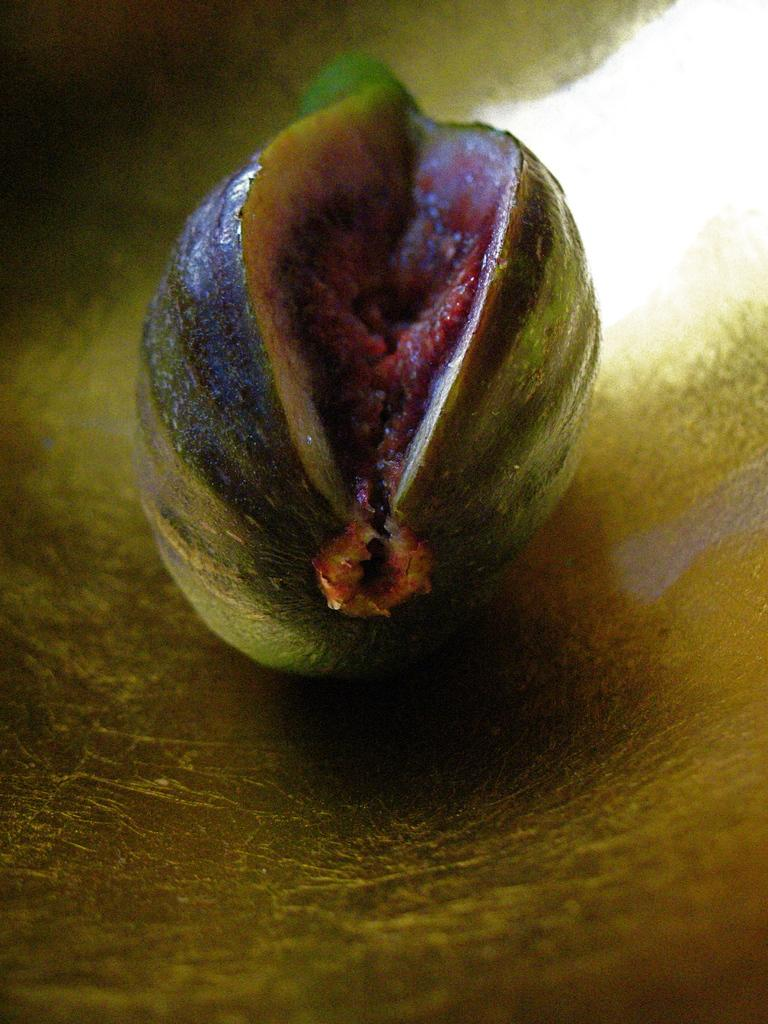What is the main subject of the image? The main subject of the image is a fruit. Can you describe the appearance of the fruit? The fruit is green and red in color. What type of thumb can be seen holding the fruit in the image? There is no thumb present in the image; it only features a fruit. Is there a rifle visible in the image? No, there is no rifle present in the image. What type of hat is the fruit wearing in the image? There is no hat present in the image, as it only features a fruit. 